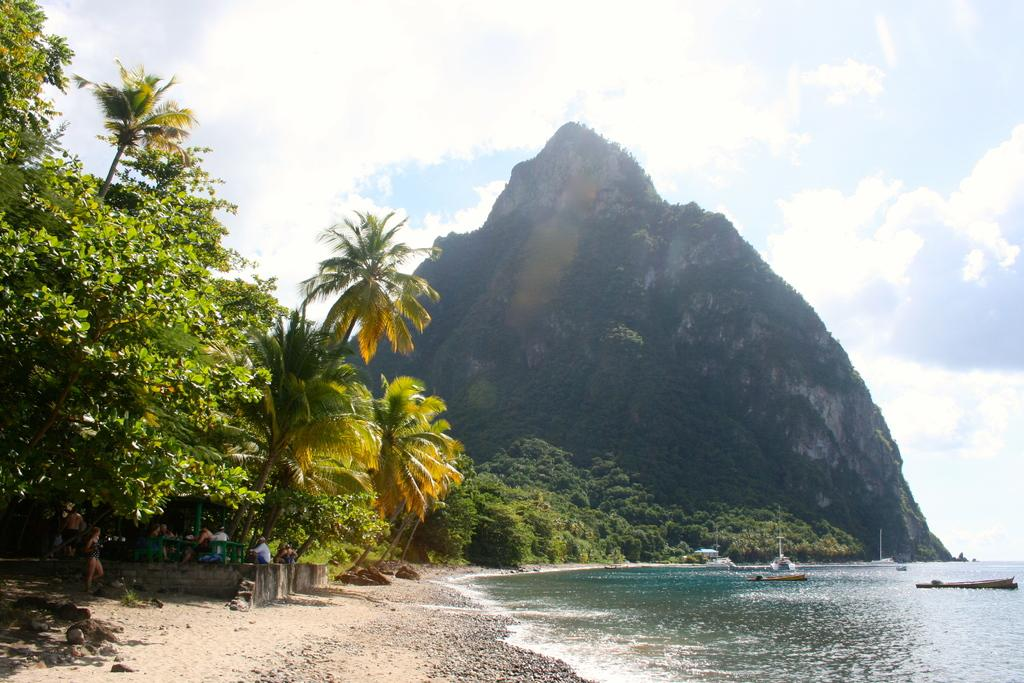What is the weather like in the image? The sky is cloudy in the image. What geographical feature can be seen in the image? There is a mountain in the image. What natural element is visible in the image? There is water visible in the image. What type of vegetation is present in the image? There are trees in the image. Where are the people located in the image? People are present under the trees in the image. What are the boats doing in the image? Boats are above the water in the image. What type of face can be seen on the mountain in the image? There is no face present on the mountain in the image. What type of care is being provided to the trees in the image? There is no indication of any care being provided to the trees in the image. 